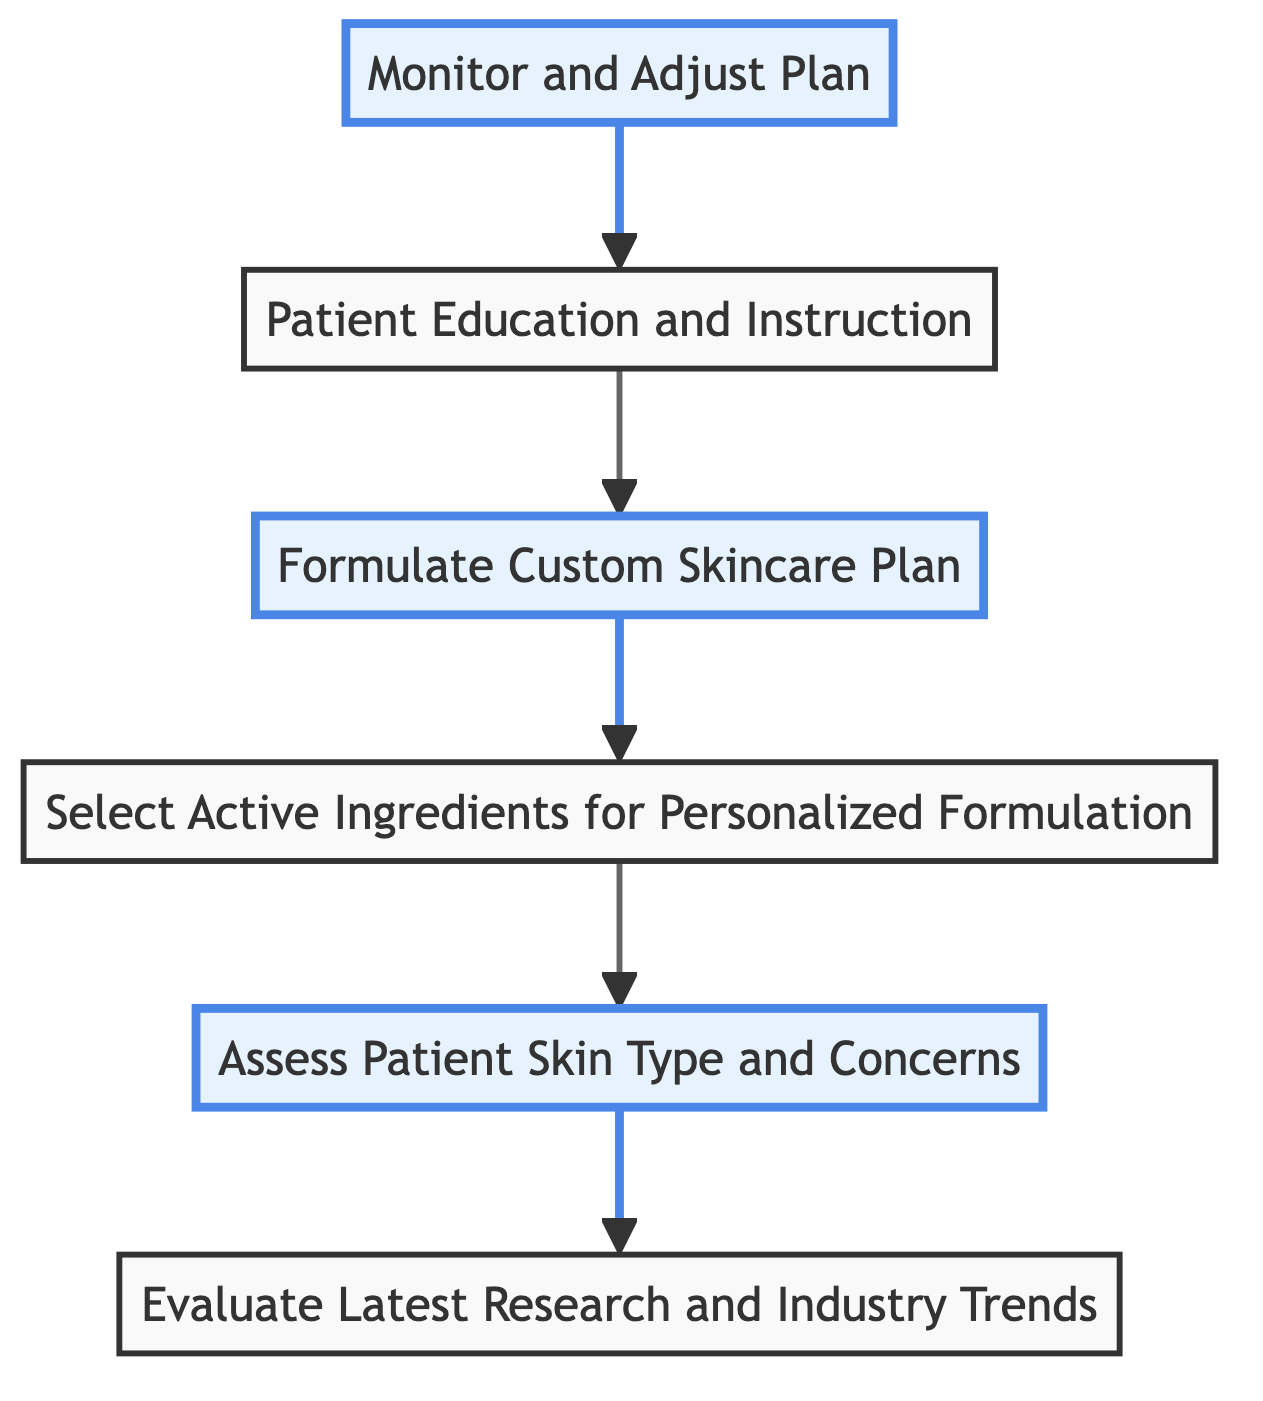What is the first step in the process? The first step in the process is listed as "Evaluate Latest Research and Industry Trends" at the bottom of the flowchart, indicating it is the starting point for creating customized skincare plans.
Answer: Evaluate Latest Research and Industry Trends How many steps are shown in the diagram? By counting the individual nodes in the flowchart, there are a total of six steps represented in the process from bottom to top.
Answer: 6 What is directly above "Patient Education and Instruction"? The node directly above "Patient Education and Instruction" is "Formulate Custom Skincare Plan," indicating that this is the step that precedes education for the patient in the skincare process.
Answer: Formulate Custom Skincare Plan Which step follows "Assess Patient Skin Type and Concerns"? The step that directly follows "Assess Patient Skin Type and Concerns" according to the flow is "Select Active Ingredients for Personalized Formulation," showing the progression in creating the skincare plan after evaluating skin type.
Answer: Select Active Ingredients for Personalized Formulation In which step do you select active ingredients? The step for selecting active ingredients is clearly shown as "Select Active Ingredients for Personalized Formulation," which indicates the specific point in the process dedicated to choosing the right ingredients for personalized skincare.
Answer: Select Active Ingredients for Personalized Formulation What is the role of "Monitor and Adjust Plan" in the overall flow? "Monitor and Adjust Plan" is positioned at the top of the flowchart, suggesting it serves as the final step, where results are evaluated and the skincare plan is adjusted based on patient feedback and progress.
Answer: Monitor and Adjust Plan How many highlighted steps are in the diagram? There are three highlighted steps in the diagram that emphasize key components of the process, which are "Monitor and Adjust Plan", "Patient Education and Instruction", "Formulate Custom Skincare Plan".
Answer: 3 What does "Evaluate Latest Research and Industry Trends" involve? This initial step involves analyzing the newest scientific studies, clinical trials, and professional forums to identify emerging skincare treatments and ingredients, foundational for tailoring skincare plans.
Answer: Analyze scientific studies and clinical trials What is the significance of "Patient Education and Instruction" in this flow? "Patient Education and Instruction" is critical as it ensures that patients understand how to use their skincare products effectively and the importance of maintaining their regimen, bridging the treatment and outcome phases.
Answer: Ensure patient understands usage and importance of regimen Which step includes follow-up and adjustments? The step that includes follow-up and adjustments in the skincare plan is "Monitor and Adjust Plan," indicating that continuous evaluation and responsiveness to patient needs are integral to the process.
Answer: Monitor and Adjust Plan 